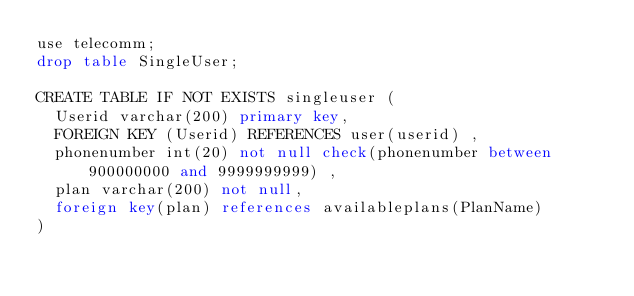Convert code to text. <code><loc_0><loc_0><loc_500><loc_500><_SQL_>use telecomm;
drop table SingleUser;

CREATE TABLE IF NOT EXISTS singleuser (
  Userid varchar(200) primary key,
  FOREIGN KEY (Userid) REFERENCES user(userid) ,
  phonenumber int(20) not null check(phonenumber between 900000000 and 9999999999) ,
  plan varchar(200) not null,
  foreign key(plan) references availableplans(PlanName)
)




</code> 